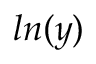<formula> <loc_0><loc_0><loc_500><loc_500>\ln ( y )</formula> 